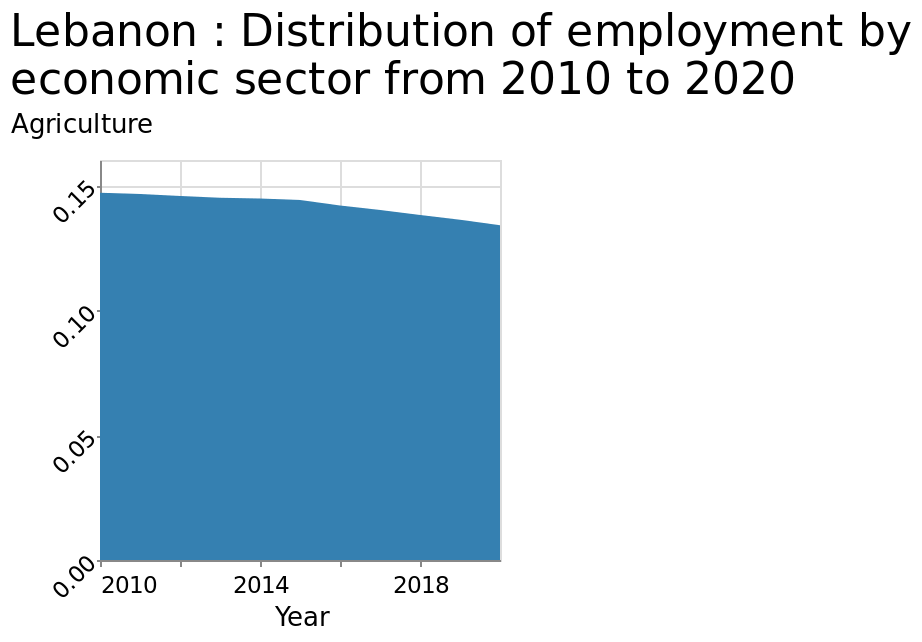<image>
What does the x-axis represent on the chart? The x-axis on the chart represents the "Year" from 2010 to 2020. How has the rate of decrease in employment changed since 2015? The rate of decrease in employment has doubled since 2015. Describe the following image in detail This is a area chart titled Lebanon : Distribution of employment by economic sector from 2010 to 2020. The y-axis measures Agriculture with scale from 0.00 to 0.15 while the x-axis shows Year with linear scale with a minimum of 2010 and a maximum of 2018. Does the x-axis on the chart represent the "Year" from 2020 to 2010? No.The x-axis on the chart represents the "Year" from 2010 to 2020. 